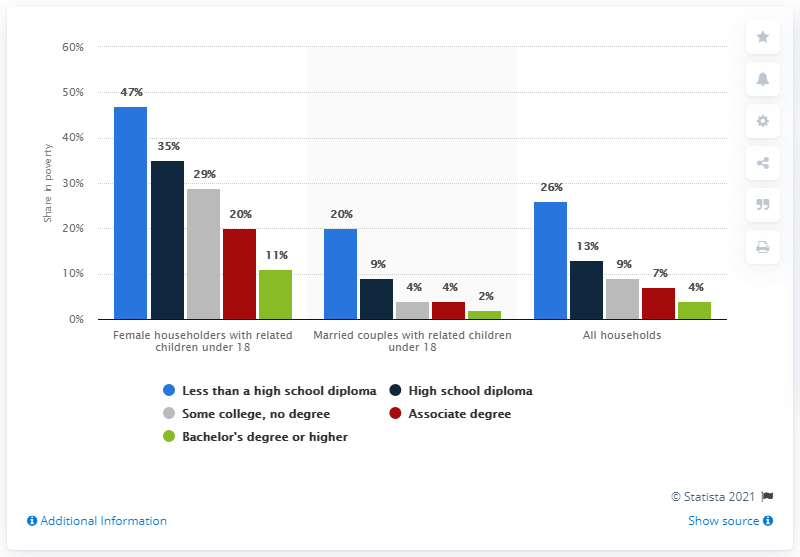Outline some significant characteristics in this image. According to the data, female householders with related children under 18 years old were asked to look for a red bar on the chart. When they found it, the value was 20%. This bar represents Associate degree holders. The "All Households data" has been added, and the percentage values have been calculated by adding them all together and dividing by the least value. The result is approximately 14.75. 